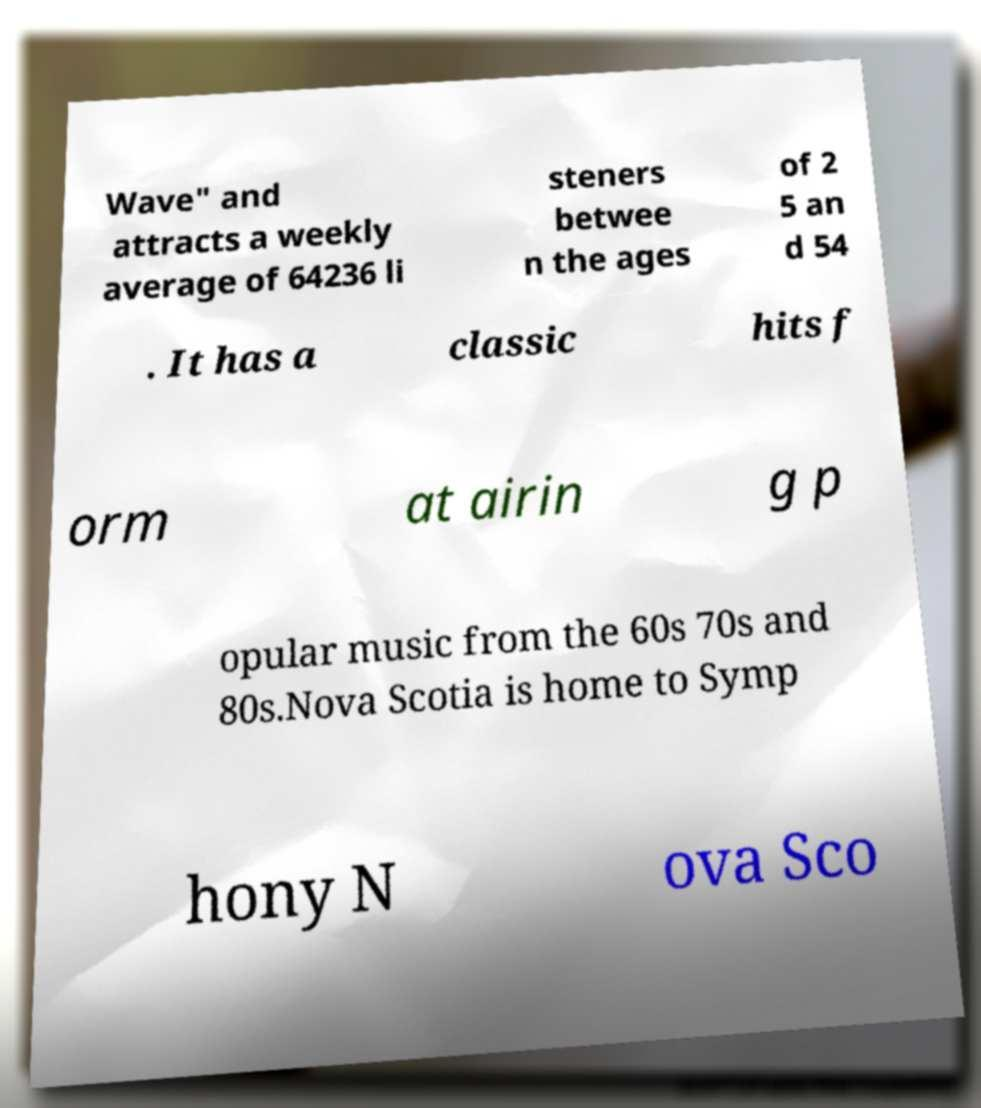Can you read and provide the text displayed in the image?This photo seems to have some interesting text. Can you extract and type it out for me? Wave" and attracts a weekly average of 64236 li steners betwee n the ages of 2 5 an d 54 . It has a classic hits f orm at airin g p opular music from the 60s 70s and 80s.Nova Scotia is home to Symp hony N ova Sco 